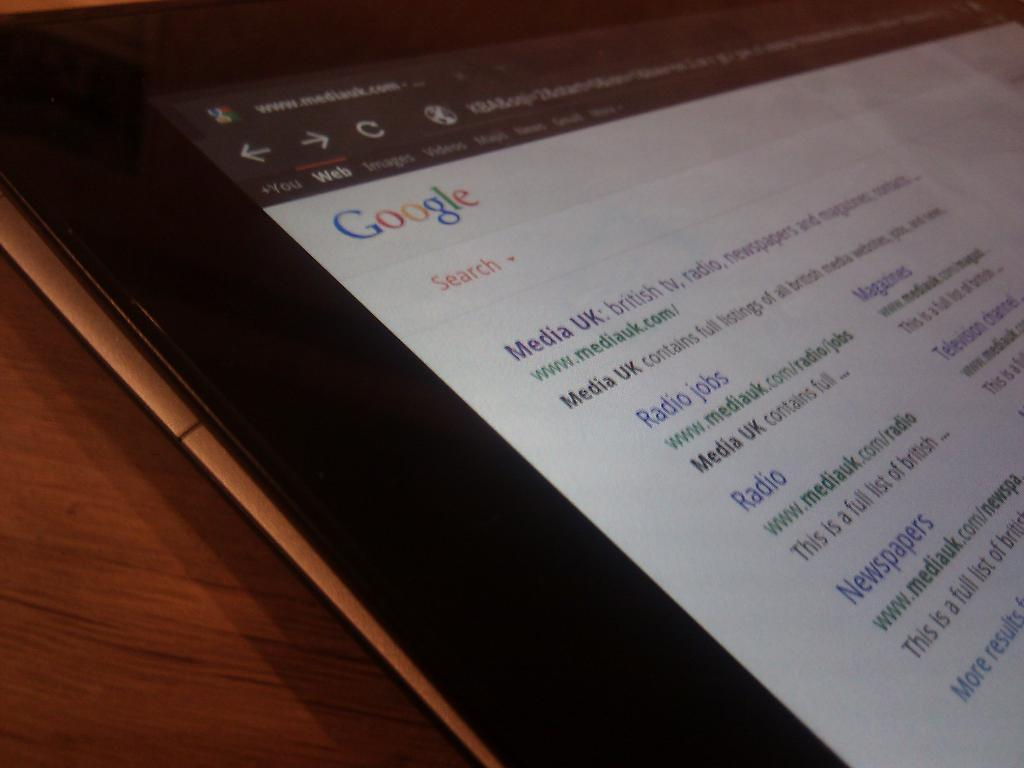What type of electronic device is in the image? There is an electronic device in the image, but the specific type is not mentioned. What feature does the electronic device have? The electronic device has a screen. What can be seen on the screen of the electronic device? A web page is visible on the screen of the electronic device. How many potatoes are being distributed on the web page visible on the screen of the electronic device? There is no mention of potatoes or distribution on the web page visible on the screen of the electronic device. 